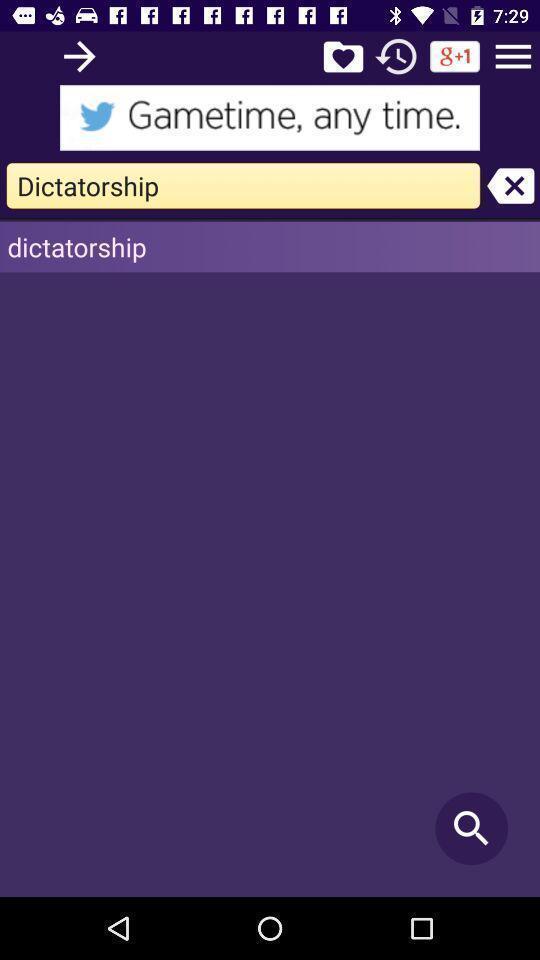Summarize the main components in this picture. Window displaying an offline dictionary. 